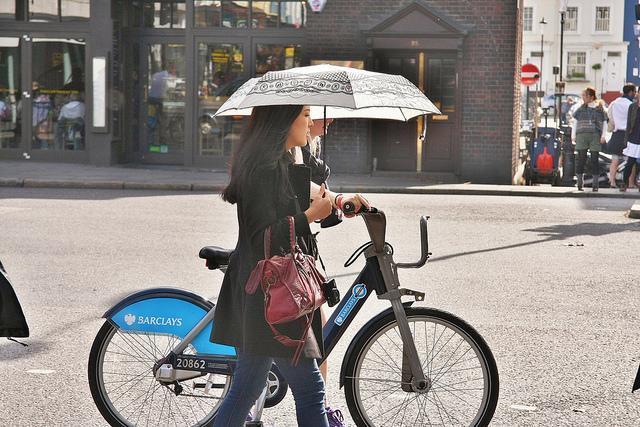How many people can be seen?
Give a very brief answer. 2. 